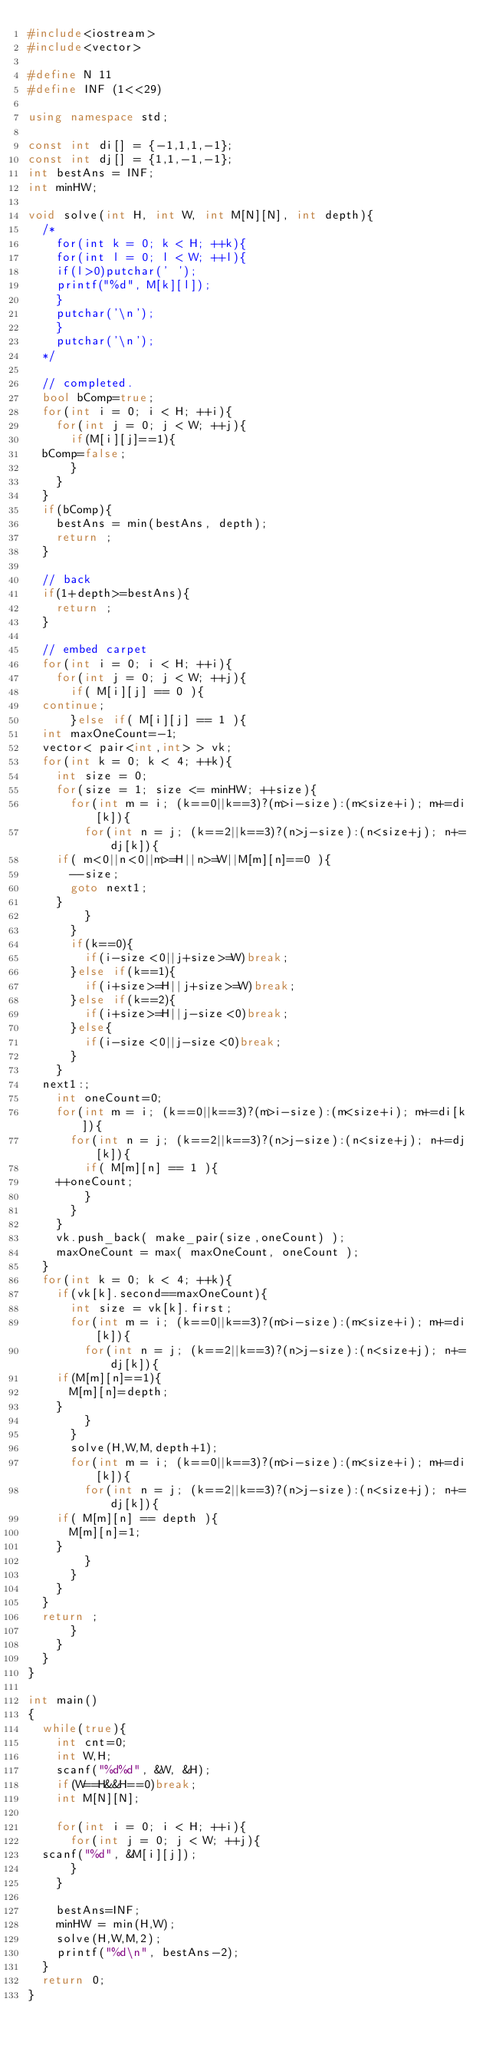Convert code to text. <code><loc_0><loc_0><loc_500><loc_500><_C++_>#include<iostream>
#include<vector>

#define N 11
#define INF (1<<29)

using namespace std;

const int di[] = {-1,1,1,-1};
const int dj[] = {1,1,-1,-1};
int bestAns = INF;
int minHW;

void solve(int H, int W, int M[N][N], int depth){
  /*
    for(int k = 0; k < H; ++k){
    for(int l = 0; l < W; ++l){
    if(l>0)putchar(' ');
    printf("%d", M[k][l]);
    }
    putchar('\n');
    }
    putchar('\n');
  */

  // completed.
  bool bComp=true;
  for(int i = 0; i < H; ++i){
    for(int j = 0; j < W; ++j){
      if(M[i][j]==1){
	bComp=false;
      }
    }
  }
  if(bComp){
    bestAns = min(bestAns, depth);
    return ;
  }

  // back
  if(1+depth>=bestAns){
    return ;
  }

  // embed carpet
  for(int i = 0; i < H; ++i){
    for(int j = 0; j < W; ++j){
      if( M[i][j] == 0 ){
	continue;
      }else if( M[i][j] == 1 ){
	int maxOneCount=-1;
	vector< pair<int,int> > vk;
	for(int k = 0; k < 4; ++k){
	  int size = 0;
	  for(size = 1; size <= minHW; ++size){
	    for(int m = i; (k==0||k==3)?(m>i-size):(m<size+i); m+=di[k]){
	      for(int n = j; (k==2||k==3)?(n>j-size):(n<size+j); n+=dj[k]){
		if( m<0||n<0||m>=H||n>=W||M[m][n]==0 ){
		  --size;
		  goto next1;
		}
	      }
	    }
	    if(k==0){
	      if(i-size<0||j+size>=W)break;
	    }else if(k==1){
	      if(i+size>=H||j+size>=W)break;
	    }else if(k==2){
	      if(i+size>=H||j-size<0)break;
	    }else{
	      if(i-size<0||j-size<0)break;
	    }
	  }
	next1:;
	  int oneCount=0;
	  for(int m = i; (k==0||k==3)?(m>i-size):(m<size+i); m+=di[k]){
	    for(int n = j; (k==2||k==3)?(n>j-size):(n<size+j); n+=dj[k]){
	      if( M[m][n] == 1 ){
		++oneCount;
	      }
	    }
	  }
	  vk.push_back( make_pair(size,oneCount) );
	  maxOneCount = max( maxOneCount, oneCount );
	}
	for(int k = 0; k < 4; ++k){
	  if(vk[k].second==maxOneCount){
	    int size = vk[k].first;
	    for(int m = i; (k==0||k==3)?(m>i-size):(m<size+i); m+=di[k]){
	      for(int n = j; (k==2||k==3)?(n>j-size):(n<size+j); n+=dj[k]){
		if(M[m][n]==1){
		  M[m][n]=depth;
		}
	      }
	    }
	    solve(H,W,M,depth+1);
	    for(int m = i; (k==0||k==3)?(m>i-size):(m<size+i); m+=di[k]){
	      for(int n = j; (k==2||k==3)?(n>j-size):(n<size+j); n+=dj[k]){
		if( M[m][n] == depth ){
		  M[m][n]=1;
		}
	      }
	    }
	  }
	}
	return ;
      }
    }
  }
}

int main()
{
  while(true){
    int cnt=0;
    int W,H;
    scanf("%d%d", &W, &H);
    if(W==H&&H==0)break;
    int M[N][N];
    
    for(int i = 0; i < H; ++i){
      for(int j = 0; j < W; ++j){
	scanf("%d", &M[i][j]);
      }
    }

    bestAns=INF;
    minHW = min(H,W);
    solve(H,W,M,2);
    printf("%d\n", bestAns-2);
  }
  return 0;
}</code> 